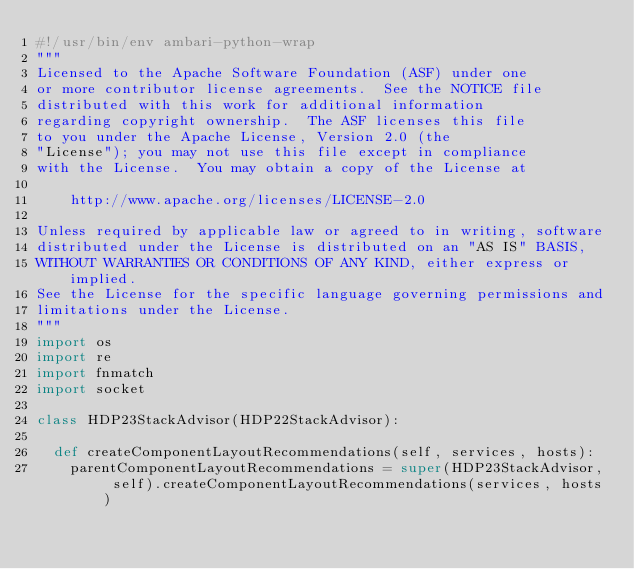Convert code to text. <code><loc_0><loc_0><loc_500><loc_500><_Python_>#!/usr/bin/env ambari-python-wrap
"""
Licensed to the Apache Software Foundation (ASF) under one
or more contributor license agreements.  See the NOTICE file
distributed with this work for additional information
regarding copyright ownership.  The ASF licenses this file
to you under the Apache License, Version 2.0 (the
"License"); you may not use this file except in compliance
with the License.  You may obtain a copy of the License at

    http://www.apache.org/licenses/LICENSE-2.0

Unless required by applicable law or agreed to in writing, software
distributed under the License is distributed on an "AS IS" BASIS,
WITHOUT WARRANTIES OR CONDITIONS OF ANY KIND, either express or implied.
See the License for the specific language governing permissions and
limitations under the License.
"""
import os
import re
import fnmatch
import socket

class HDP23StackAdvisor(HDP22StackAdvisor):

  def createComponentLayoutRecommendations(self, services, hosts):
    parentComponentLayoutRecommendations = super(HDP23StackAdvisor, self).createComponentLayoutRecommendations(services, hosts)
</code> 